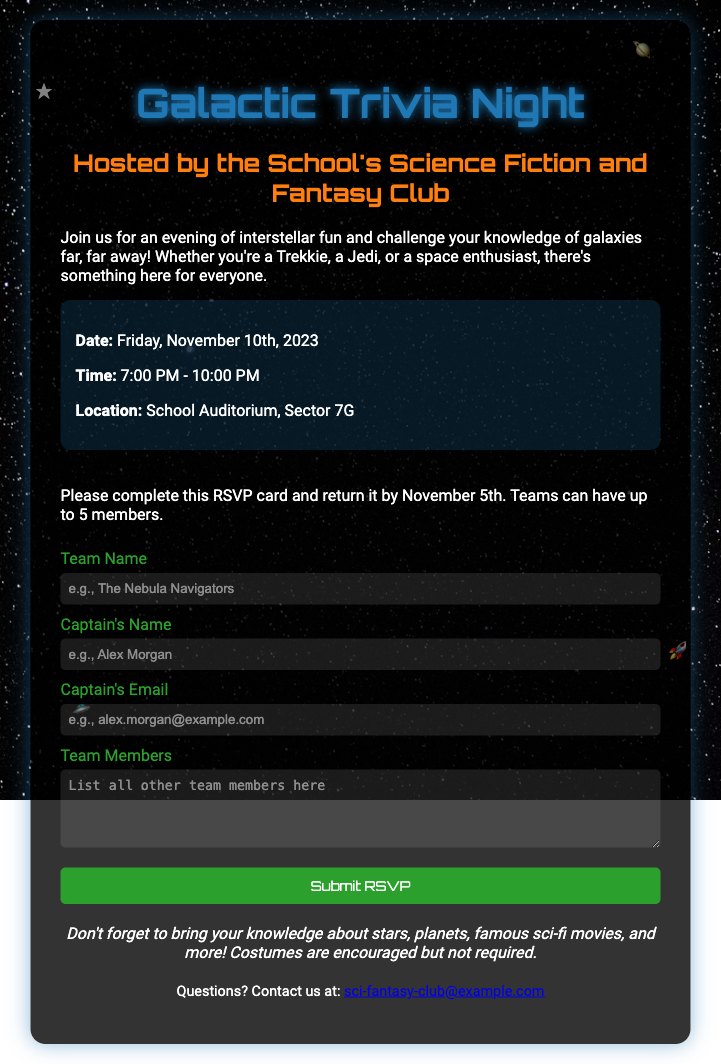What is the date of the event? The date of the event is explicitly mentioned in the document as "Friday, November 10th, 2023."
Answer: Friday, November 10th, 2023 What is the location of the event? The location is provided in the document as "School Auditorium, Sector 7G."
Answer: School Auditorium, Sector 7G How many members can a team have? The maximum number of team members is stated in the RSVP section: "Teams can have up to 5 members."
Answer: 5 Who is hosting the event? The host of the event is mentioned, which is "the School's Science Fiction and Fantasy Club."
Answer: School's Science Fiction and Fantasy Club What should participants bring? The document suggests that participants should bring knowledge about various topics, specifically stars, planets, and famous sci-fi movies.
Answer: Knowledge about stars, planets, and famous sci-fi movies What type of attire is encouraged? The RSVP card notes that "Costumes are encouraged but not required," indicating that themed attire is welcomed.
Answer: Costumes What is the RSVP submission deadline? The deadline to return the RSVP card is clearly stated: "by November 5th."
Answer: November 5th What is the contact email for questions? The document provides a contact email for questions as "sci-fantasy-club@example.com."
Answer: sci-fantasy-club@example.com 